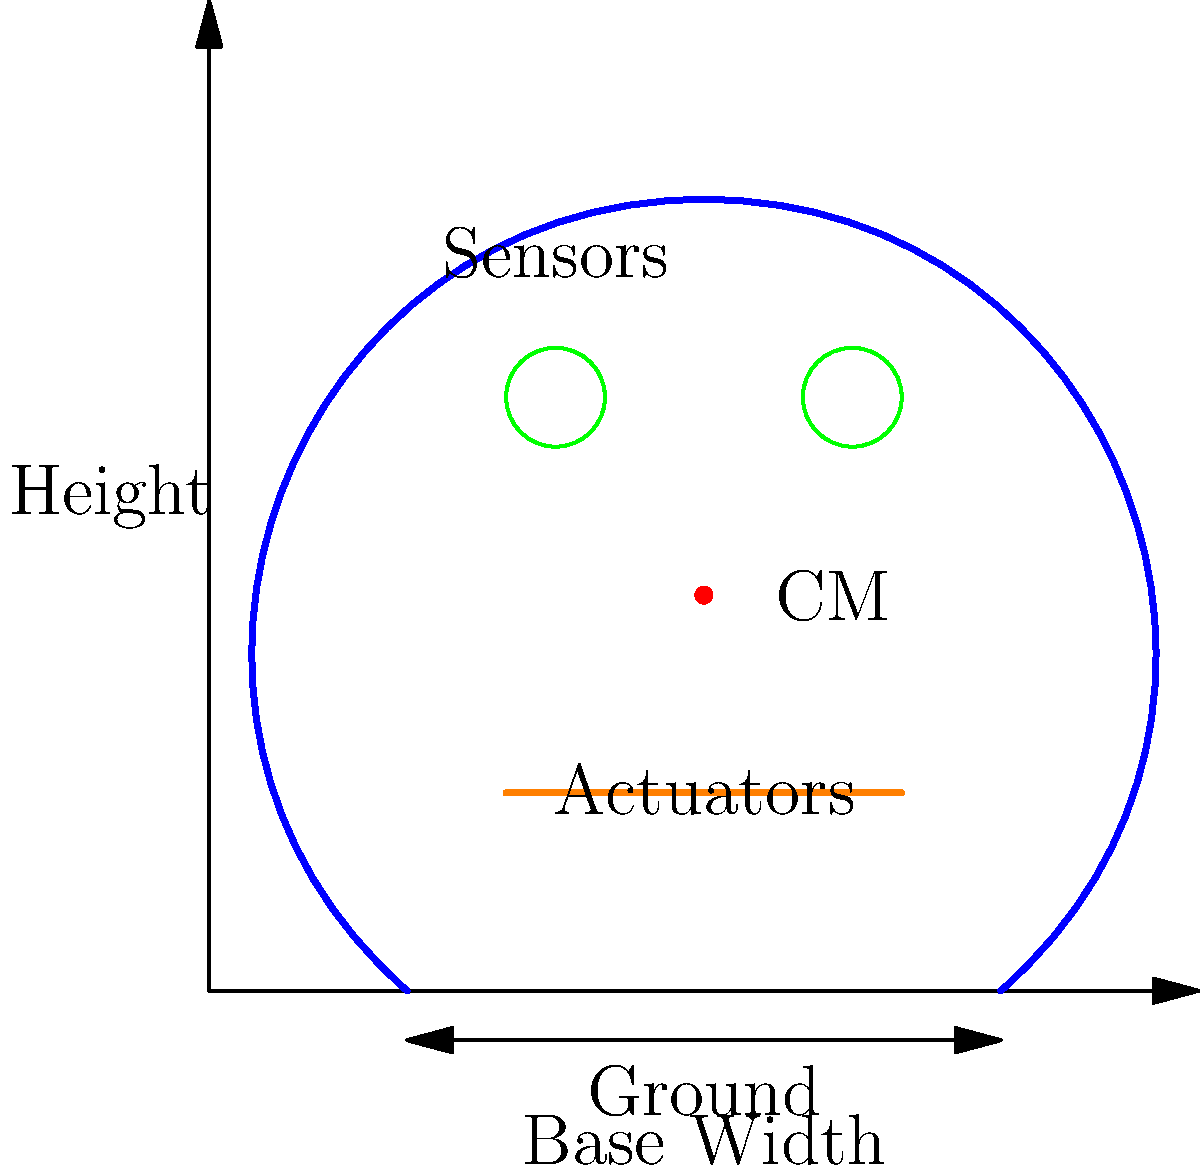In designing an earthquake-resistant structure inspired by robotic balance systems, which principle is most crucial for maintaining stability during seismic events, and how does it relate to the center of mass (CM) shown in the diagram? To answer this question, let's consider the key principles of earthquake-resistant design and how they relate to robotic balance systems:

1. Low center of mass: In robotics, a lower center of mass provides better stability. For buildings, this translates to concentrating more mass in the lower levels.

2. Wide base: Robots with a wider base are more stable. In structural design, this corresponds to a wider foundation or a broader footprint for the building.

3. Flexibility and damping: Robotic systems often use flexible joints and dampers to absorb shocks. In buildings, this is achieved through base isolation systems and dampers.

4. Active control systems: Advanced robots use sensors and actuators for real-time balance adjustments. Similarly, some modern buildings incorporate active mass damper systems.

5. Symmetry: Both robots and buildings benefit from symmetrical design to evenly distribute forces.

Considering the diagram, the most crucial principle for maintaining stability during seismic events is the relationship between the center of mass (CM) and the base width. A lower CM relative to a wider base provides better stability, as it reduces the moment arm that could cause toppling during an earthquake.

The structure in the diagram shows:
- A relatively low CM compared to the total height
- A wide base in relation to the height
- Sensors at the top (possibly for monitoring movement)
- Actuators near the base (possibly for active control)

These elements combine principles from robotic balance systems with traditional earthquake-resistant design. The low CM and wide base are particularly important for passive stability, while the sensors and actuators suggest an active control system for enhanced performance during seismic events.
Answer: Low center of mass relative to a wide base 